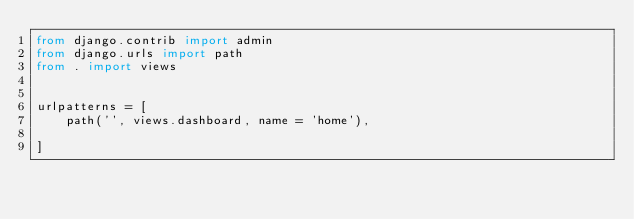Convert code to text. <code><loc_0><loc_0><loc_500><loc_500><_Python_>from django.contrib import admin
from django.urls import path
from . import views


urlpatterns = [
    path('', views.dashboard, name = 'home'),
    
]
</code> 